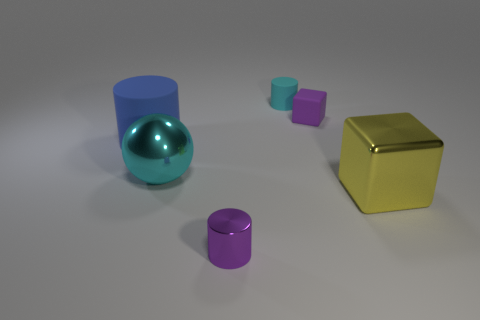Add 1 matte objects. How many objects exist? 7 Subtract all matte cylinders. How many cylinders are left? 1 Subtract all cyan cylinders. How many cylinders are left? 2 Subtract all cubes. How many objects are left? 4 Add 2 big shiny cubes. How many big shiny cubes are left? 3 Add 4 yellow metal cubes. How many yellow metal cubes exist? 5 Subtract 0 gray cubes. How many objects are left? 6 Subtract all red spheres. Subtract all cyan cubes. How many spheres are left? 1 Subtract all matte spheres. Subtract all cylinders. How many objects are left? 3 